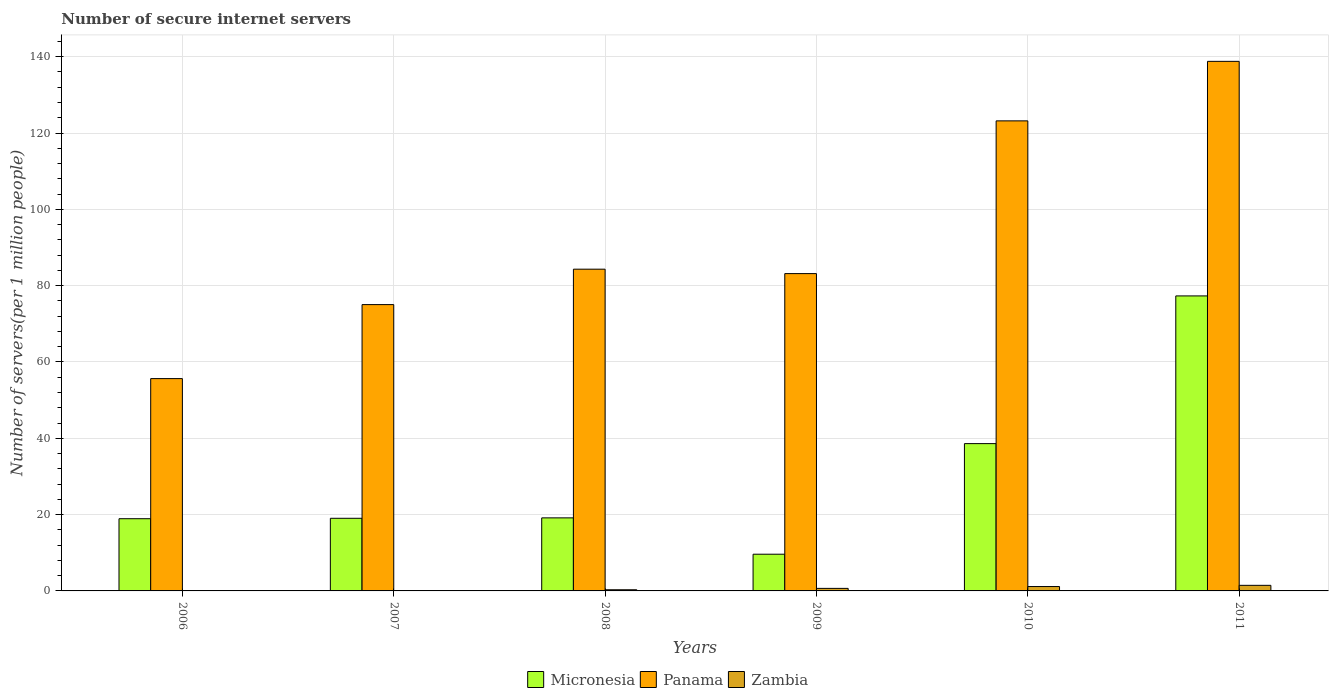How many different coloured bars are there?
Ensure brevity in your answer.  3. How many groups of bars are there?
Offer a terse response. 6. Are the number of bars per tick equal to the number of legend labels?
Make the answer very short. Yes. Are the number of bars on each tick of the X-axis equal?
Provide a succinct answer. Yes. How many bars are there on the 6th tick from the left?
Offer a very short reply. 3. What is the label of the 4th group of bars from the left?
Offer a very short reply. 2009. In how many cases, is the number of bars for a given year not equal to the number of legend labels?
Provide a succinct answer. 0. What is the number of secure internet servers in Zambia in 2006?
Your answer should be compact. 0.08. Across all years, what is the maximum number of secure internet servers in Zambia?
Offer a very short reply. 1.46. Across all years, what is the minimum number of secure internet servers in Micronesia?
Your answer should be very brief. 9.62. What is the total number of secure internet servers in Panama in the graph?
Your answer should be compact. 560.13. What is the difference between the number of secure internet servers in Panama in 2006 and that in 2009?
Ensure brevity in your answer.  -27.52. What is the difference between the number of secure internet servers in Zambia in 2007 and the number of secure internet servers in Micronesia in 2006?
Your answer should be very brief. -18.85. What is the average number of secure internet servers in Zambia per year?
Your answer should be very brief. 0.62. In the year 2010, what is the difference between the number of secure internet servers in Micronesia and number of secure internet servers in Panama?
Your answer should be compact. -84.58. What is the ratio of the number of secure internet servers in Panama in 2006 to that in 2010?
Your response must be concise. 0.45. Is the difference between the number of secure internet servers in Micronesia in 2009 and 2010 greater than the difference between the number of secure internet servers in Panama in 2009 and 2010?
Give a very brief answer. Yes. What is the difference between the highest and the second highest number of secure internet servers in Zambia?
Ensure brevity in your answer.  0.31. What is the difference between the highest and the lowest number of secure internet servers in Zambia?
Your answer should be compact. 1.39. In how many years, is the number of secure internet servers in Micronesia greater than the average number of secure internet servers in Micronesia taken over all years?
Your answer should be very brief. 2. What does the 2nd bar from the left in 2009 represents?
Offer a very short reply. Panama. What does the 2nd bar from the right in 2008 represents?
Give a very brief answer. Panama. Is it the case that in every year, the sum of the number of secure internet servers in Zambia and number of secure internet servers in Panama is greater than the number of secure internet servers in Micronesia?
Ensure brevity in your answer.  Yes. What is the difference between two consecutive major ticks on the Y-axis?
Make the answer very short. 20. Are the values on the major ticks of Y-axis written in scientific E-notation?
Offer a terse response. No. Does the graph contain any zero values?
Your answer should be compact. No. Where does the legend appear in the graph?
Provide a succinct answer. Bottom center. How are the legend labels stacked?
Your answer should be compact. Horizontal. What is the title of the graph?
Ensure brevity in your answer.  Number of secure internet servers. Does "Namibia" appear as one of the legend labels in the graph?
Provide a succinct answer. No. What is the label or title of the X-axis?
Provide a succinct answer. Years. What is the label or title of the Y-axis?
Keep it short and to the point. Number of servers(per 1 million people). What is the Number of servers(per 1 million people) of Micronesia in 2006?
Provide a short and direct response. 18.93. What is the Number of servers(per 1 million people) of Panama in 2006?
Ensure brevity in your answer.  55.64. What is the Number of servers(per 1 million people) in Zambia in 2006?
Offer a terse response. 0.08. What is the Number of servers(per 1 million people) in Micronesia in 2007?
Offer a very short reply. 19.03. What is the Number of servers(per 1 million people) in Panama in 2007?
Make the answer very short. 75.03. What is the Number of servers(per 1 million people) in Zambia in 2007?
Keep it short and to the point. 0.08. What is the Number of servers(per 1 million people) of Micronesia in 2008?
Keep it short and to the point. 19.14. What is the Number of servers(per 1 million people) of Panama in 2008?
Offer a very short reply. 84.32. What is the Number of servers(per 1 million people) of Zambia in 2008?
Your answer should be very brief. 0.31. What is the Number of servers(per 1 million people) of Micronesia in 2009?
Offer a very short reply. 9.62. What is the Number of servers(per 1 million people) in Panama in 2009?
Your answer should be compact. 83.16. What is the Number of servers(per 1 million people) in Zambia in 2009?
Your answer should be compact. 0.67. What is the Number of servers(per 1 million people) of Micronesia in 2010?
Provide a succinct answer. 38.6. What is the Number of servers(per 1 million people) in Panama in 2010?
Offer a very short reply. 123.19. What is the Number of servers(per 1 million people) in Zambia in 2010?
Your answer should be compact. 1.15. What is the Number of servers(per 1 million people) in Micronesia in 2011?
Give a very brief answer. 77.31. What is the Number of servers(per 1 million people) of Panama in 2011?
Provide a short and direct response. 138.78. What is the Number of servers(per 1 million people) in Zambia in 2011?
Your answer should be very brief. 1.46. Across all years, what is the maximum Number of servers(per 1 million people) of Micronesia?
Your answer should be very brief. 77.31. Across all years, what is the maximum Number of servers(per 1 million people) of Panama?
Offer a very short reply. 138.78. Across all years, what is the maximum Number of servers(per 1 million people) of Zambia?
Keep it short and to the point. 1.46. Across all years, what is the minimum Number of servers(per 1 million people) in Micronesia?
Your answer should be very brief. 9.62. Across all years, what is the minimum Number of servers(per 1 million people) in Panama?
Give a very brief answer. 55.64. Across all years, what is the minimum Number of servers(per 1 million people) of Zambia?
Provide a succinct answer. 0.08. What is the total Number of servers(per 1 million people) in Micronesia in the graph?
Provide a short and direct response. 182.64. What is the total Number of servers(per 1 million people) in Panama in the graph?
Your answer should be very brief. 560.13. What is the total Number of servers(per 1 million people) of Zambia in the graph?
Your response must be concise. 3.74. What is the difference between the Number of servers(per 1 million people) of Micronesia in 2006 and that in 2007?
Provide a short and direct response. -0.11. What is the difference between the Number of servers(per 1 million people) of Panama in 2006 and that in 2007?
Ensure brevity in your answer.  -19.39. What is the difference between the Number of servers(per 1 million people) in Zambia in 2006 and that in 2007?
Make the answer very short. 0. What is the difference between the Number of servers(per 1 million people) in Micronesia in 2006 and that in 2008?
Ensure brevity in your answer.  -0.22. What is the difference between the Number of servers(per 1 million people) of Panama in 2006 and that in 2008?
Provide a short and direct response. -28.67. What is the difference between the Number of servers(per 1 million people) in Zambia in 2006 and that in 2008?
Ensure brevity in your answer.  -0.22. What is the difference between the Number of servers(per 1 million people) of Micronesia in 2006 and that in 2009?
Make the answer very short. 9.31. What is the difference between the Number of servers(per 1 million people) of Panama in 2006 and that in 2009?
Your answer should be compact. -27.52. What is the difference between the Number of servers(per 1 million people) in Zambia in 2006 and that in 2009?
Provide a succinct answer. -0.59. What is the difference between the Number of servers(per 1 million people) of Micronesia in 2006 and that in 2010?
Offer a terse response. -19.68. What is the difference between the Number of servers(per 1 million people) of Panama in 2006 and that in 2010?
Your answer should be compact. -67.54. What is the difference between the Number of servers(per 1 million people) in Zambia in 2006 and that in 2010?
Give a very brief answer. -1.07. What is the difference between the Number of servers(per 1 million people) in Micronesia in 2006 and that in 2011?
Offer a terse response. -58.39. What is the difference between the Number of servers(per 1 million people) in Panama in 2006 and that in 2011?
Offer a very short reply. -83.14. What is the difference between the Number of servers(per 1 million people) in Zambia in 2006 and that in 2011?
Your answer should be compact. -1.38. What is the difference between the Number of servers(per 1 million people) of Micronesia in 2007 and that in 2008?
Your answer should be very brief. -0.11. What is the difference between the Number of servers(per 1 million people) of Panama in 2007 and that in 2008?
Keep it short and to the point. -9.28. What is the difference between the Number of servers(per 1 million people) in Zambia in 2007 and that in 2008?
Make the answer very short. -0.23. What is the difference between the Number of servers(per 1 million people) of Micronesia in 2007 and that in 2009?
Make the answer very short. 9.41. What is the difference between the Number of servers(per 1 million people) of Panama in 2007 and that in 2009?
Offer a very short reply. -8.13. What is the difference between the Number of servers(per 1 million people) of Zambia in 2007 and that in 2009?
Give a very brief answer. -0.59. What is the difference between the Number of servers(per 1 million people) in Micronesia in 2007 and that in 2010?
Provide a succinct answer. -19.57. What is the difference between the Number of servers(per 1 million people) in Panama in 2007 and that in 2010?
Ensure brevity in your answer.  -48.15. What is the difference between the Number of servers(per 1 million people) in Zambia in 2007 and that in 2010?
Make the answer very short. -1.07. What is the difference between the Number of servers(per 1 million people) of Micronesia in 2007 and that in 2011?
Provide a succinct answer. -58.28. What is the difference between the Number of servers(per 1 million people) of Panama in 2007 and that in 2011?
Your answer should be very brief. -63.75. What is the difference between the Number of servers(per 1 million people) of Zambia in 2007 and that in 2011?
Your answer should be very brief. -1.39. What is the difference between the Number of servers(per 1 million people) in Micronesia in 2008 and that in 2009?
Make the answer very short. 9.52. What is the difference between the Number of servers(per 1 million people) in Panama in 2008 and that in 2009?
Give a very brief answer. 1.16. What is the difference between the Number of servers(per 1 million people) of Zambia in 2008 and that in 2009?
Ensure brevity in your answer.  -0.36. What is the difference between the Number of servers(per 1 million people) of Micronesia in 2008 and that in 2010?
Make the answer very short. -19.46. What is the difference between the Number of servers(per 1 million people) of Panama in 2008 and that in 2010?
Your response must be concise. -38.87. What is the difference between the Number of servers(per 1 million people) of Zambia in 2008 and that in 2010?
Provide a succinct answer. -0.84. What is the difference between the Number of servers(per 1 million people) in Micronesia in 2008 and that in 2011?
Keep it short and to the point. -58.17. What is the difference between the Number of servers(per 1 million people) in Panama in 2008 and that in 2011?
Ensure brevity in your answer.  -54.47. What is the difference between the Number of servers(per 1 million people) of Zambia in 2008 and that in 2011?
Provide a succinct answer. -1.16. What is the difference between the Number of servers(per 1 million people) of Micronesia in 2009 and that in 2010?
Make the answer very short. -28.98. What is the difference between the Number of servers(per 1 million people) of Panama in 2009 and that in 2010?
Make the answer very short. -40.03. What is the difference between the Number of servers(per 1 million people) of Zambia in 2009 and that in 2010?
Provide a succinct answer. -0.48. What is the difference between the Number of servers(per 1 million people) of Micronesia in 2009 and that in 2011?
Your answer should be compact. -67.69. What is the difference between the Number of servers(per 1 million people) in Panama in 2009 and that in 2011?
Your response must be concise. -55.62. What is the difference between the Number of servers(per 1 million people) of Zambia in 2009 and that in 2011?
Give a very brief answer. -0.8. What is the difference between the Number of servers(per 1 million people) in Micronesia in 2010 and that in 2011?
Provide a short and direct response. -38.71. What is the difference between the Number of servers(per 1 million people) of Panama in 2010 and that in 2011?
Your answer should be very brief. -15.6. What is the difference between the Number of servers(per 1 million people) of Zambia in 2010 and that in 2011?
Offer a very short reply. -0.31. What is the difference between the Number of servers(per 1 million people) of Micronesia in 2006 and the Number of servers(per 1 million people) of Panama in 2007?
Make the answer very short. -56.11. What is the difference between the Number of servers(per 1 million people) of Micronesia in 2006 and the Number of servers(per 1 million people) of Zambia in 2007?
Give a very brief answer. 18.85. What is the difference between the Number of servers(per 1 million people) in Panama in 2006 and the Number of servers(per 1 million people) in Zambia in 2007?
Offer a very short reply. 55.57. What is the difference between the Number of servers(per 1 million people) in Micronesia in 2006 and the Number of servers(per 1 million people) in Panama in 2008?
Offer a very short reply. -65.39. What is the difference between the Number of servers(per 1 million people) of Micronesia in 2006 and the Number of servers(per 1 million people) of Zambia in 2008?
Your answer should be compact. 18.62. What is the difference between the Number of servers(per 1 million people) of Panama in 2006 and the Number of servers(per 1 million people) of Zambia in 2008?
Keep it short and to the point. 55.34. What is the difference between the Number of servers(per 1 million people) of Micronesia in 2006 and the Number of servers(per 1 million people) of Panama in 2009?
Offer a terse response. -64.23. What is the difference between the Number of servers(per 1 million people) of Micronesia in 2006 and the Number of servers(per 1 million people) of Zambia in 2009?
Provide a short and direct response. 18.26. What is the difference between the Number of servers(per 1 million people) of Panama in 2006 and the Number of servers(per 1 million people) of Zambia in 2009?
Make the answer very short. 54.98. What is the difference between the Number of servers(per 1 million people) of Micronesia in 2006 and the Number of servers(per 1 million people) of Panama in 2010?
Your response must be concise. -104.26. What is the difference between the Number of servers(per 1 million people) of Micronesia in 2006 and the Number of servers(per 1 million people) of Zambia in 2010?
Ensure brevity in your answer.  17.78. What is the difference between the Number of servers(per 1 million people) in Panama in 2006 and the Number of servers(per 1 million people) in Zambia in 2010?
Your answer should be compact. 54.49. What is the difference between the Number of servers(per 1 million people) in Micronesia in 2006 and the Number of servers(per 1 million people) in Panama in 2011?
Provide a short and direct response. -119.86. What is the difference between the Number of servers(per 1 million people) of Micronesia in 2006 and the Number of servers(per 1 million people) of Zambia in 2011?
Make the answer very short. 17.46. What is the difference between the Number of servers(per 1 million people) in Panama in 2006 and the Number of servers(per 1 million people) in Zambia in 2011?
Your response must be concise. 54.18. What is the difference between the Number of servers(per 1 million people) in Micronesia in 2007 and the Number of servers(per 1 million people) in Panama in 2008?
Ensure brevity in your answer.  -65.28. What is the difference between the Number of servers(per 1 million people) of Micronesia in 2007 and the Number of servers(per 1 million people) of Zambia in 2008?
Ensure brevity in your answer.  18.73. What is the difference between the Number of servers(per 1 million people) of Panama in 2007 and the Number of servers(per 1 million people) of Zambia in 2008?
Ensure brevity in your answer.  74.73. What is the difference between the Number of servers(per 1 million people) of Micronesia in 2007 and the Number of servers(per 1 million people) of Panama in 2009?
Your response must be concise. -64.13. What is the difference between the Number of servers(per 1 million people) in Micronesia in 2007 and the Number of servers(per 1 million people) in Zambia in 2009?
Ensure brevity in your answer.  18.37. What is the difference between the Number of servers(per 1 million people) of Panama in 2007 and the Number of servers(per 1 million people) of Zambia in 2009?
Your answer should be very brief. 74.37. What is the difference between the Number of servers(per 1 million people) of Micronesia in 2007 and the Number of servers(per 1 million people) of Panama in 2010?
Offer a very short reply. -104.15. What is the difference between the Number of servers(per 1 million people) in Micronesia in 2007 and the Number of servers(per 1 million people) in Zambia in 2010?
Offer a terse response. 17.88. What is the difference between the Number of servers(per 1 million people) of Panama in 2007 and the Number of servers(per 1 million people) of Zambia in 2010?
Give a very brief answer. 73.89. What is the difference between the Number of servers(per 1 million people) in Micronesia in 2007 and the Number of servers(per 1 million people) in Panama in 2011?
Make the answer very short. -119.75. What is the difference between the Number of servers(per 1 million people) in Micronesia in 2007 and the Number of servers(per 1 million people) in Zambia in 2011?
Keep it short and to the point. 17.57. What is the difference between the Number of servers(per 1 million people) in Panama in 2007 and the Number of servers(per 1 million people) in Zambia in 2011?
Offer a very short reply. 73.57. What is the difference between the Number of servers(per 1 million people) of Micronesia in 2008 and the Number of servers(per 1 million people) of Panama in 2009?
Offer a very short reply. -64.02. What is the difference between the Number of servers(per 1 million people) of Micronesia in 2008 and the Number of servers(per 1 million people) of Zambia in 2009?
Offer a very short reply. 18.48. What is the difference between the Number of servers(per 1 million people) in Panama in 2008 and the Number of servers(per 1 million people) in Zambia in 2009?
Provide a short and direct response. 83.65. What is the difference between the Number of servers(per 1 million people) of Micronesia in 2008 and the Number of servers(per 1 million people) of Panama in 2010?
Ensure brevity in your answer.  -104.04. What is the difference between the Number of servers(per 1 million people) in Micronesia in 2008 and the Number of servers(per 1 million people) in Zambia in 2010?
Offer a terse response. 17.99. What is the difference between the Number of servers(per 1 million people) of Panama in 2008 and the Number of servers(per 1 million people) of Zambia in 2010?
Provide a short and direct response. 83.17. What is the difference between the Number of servers(per 1 million people) of Micronesia in 2008 and the Number of servers(per 1 million people) of Panama in 2011?
Provide a short and direct response. -119.64. What is the difference between the Number of servers(per 1 million people) of Micronesia in 2008 and the Number of servers(per 1 million people) of Zambia in 2011?
Offer a very short reply. 17.68. What is the difference between the Number of servers(per 1 million people) in Panama in 2008 and the Number of servers(per 1 million people) in Zambia in 2011?
Your answer should be very brief. 82.85. What is the difference between the Number of servers(per 1 million people) of Micronesia in 2009 and the Number of servers(per 1 million people) of Panama in 2010?
Ensure brevity in your answer.  -113.57. What is the difference between the Number of servers(per 1 million people) of Micronesia in 2009 and the Number of servers(per 1 million people) of Zambia in 2010?
Make the answer very short. 8.47. What is the difference between the Number of servers(per 1 million people) of Panama in 2009 and the Number of servers(per 1 million people) of Zambia in 2010?
Your answer should be compact. 82.01. What is the difference between the Number of servers(per 1 million people) in Micronesia in 2009 and the Number of servers(per 1 million people) in Panama in 2011?
Your response must be concise. -129.17. What is the difference between the Number of servers(per 1 million people) in Micronesia in 2009 and the Number of servers(per 1 million people) in Zambia in 2011?
Offer a terse response. 8.15. What is the difference between the Number of servers(per 1 million people) of Panama in 2009 and the Number of servers(per 1 million people) of Zambia in 2011?
Provide a succinct answer. 81.7. What is the difference between the Number of servers(per 1 million people) of Micronesia in 2010 and the Number of servers(per 1 million people) of Panama in 2011?
Your response must be concise. -100.18. What is the difference between the Number of servers(per 1 million people) of Micronesia in 2010 and the Number of servers(per 1 million people) of Zambia in 2011?
Your response must be concise. 37.14. What is the difference between the Number of servers(per 1 million people) in Panama in 2010 and the Number of servers(per 1 million people) in Zambia in 2011?
Offer a terse response. 121.72. What is the average Number of servers(per 1 million people) in Micronesia per year?
Your answer should be very brief. 30.44. What is the average Number of servers(per 1 million people) of Panama per year?
Keep it short and to the point. 93.35. What is the average Number of servers(per 1 million people) in Zambia per year?
Provide a succinct answer. 0.62. In the year 2006, what is the difference between the Number of servers(per 1 million people) of Micronesia and Number of servers(per 1 million people) of Panama?
Offer a terse response. -36.72. In the year 2006, what is the difference between the Number of servers(per 1 million people) in Micronesia and Number of servers(per 1 million people) in Zambia?
Your answer should be compact. 18.84. In the year 2006, what is the difference between the Number of servers(per 1 million people) of Panama and Number of servers(per 1 million people) of Zambia?
Offer a terse response. 55.56. In the year 2007, what is the difference between the Number of servers(per 1 million people) of Micronesia and Number of servers(per 1 million people) of Panama?
Your response must be concise. -56. In the year 2007, what is the difference between the Number of servers(per 1 million people) of Micronesia and Number of servers(per 1 million people) of Zambia?
Ensure brevity in your answer.  18.95. In the year 2007, what is the difference between the Number of servers(per 1 million people) of Panama and Number of servers(per 1 million people) of Zambia?
Offer a very short reply. 74.96. In the year 2008, what is the difference between the Number of servers(per 1 million people) in Micronesia and Number of servers(per 1 million people) in Panama?
Give a very brief answer. -65.17. In the year 2008, what is the difference between the Number of servers(per 1 million people) in Micronesia and Number of servers(per 1 million people) in Zambia?
Your response must be concise. 18.84. In the year 2008, what is the difference between the Number of servers(per 1 million people) of Panama and Number of servers(per 1 million people) of Zambia?
Your response must be concise. 84.01. In the year 2009, what is the difference between the Number of servers(per 1 million people) of Micronesia and Number of servers(per 1 million people) of Panama?
Ensure brevity in your answer.  -73.54. In the year 2009, what is the difference between the Number of servers(per 1 million people) in Micronesia and Number of servers(per 1 million people) in Zambia?
Your response must be concise. 8.95. In the year 2009, what is the difference between the Number of servers(per 1 million people) in Panama and Number of servers(per 1 million people) in Zambia?
Ensure brevity in your answer.  82.49. In the year 2010, what is the difference between the Number of servers(per 1 million people) in Micronesia and Number of servers(per 1 million people) in Panama?
Make the answer very short. -84.58. In the year 2010, what is the difference between the Number of servers(per 1 million people) of Micronesia and Number of servers(per 1 million people) of Zambia?
Provide a short and direct response. 37.45. In the year 2010, what is the difference between the Number of servers(per 1 million people) of Panama and Number of servers(per 1 million people) of Zambia?
Your answer should be very brief. 122.04. In the year 2011, what is the difference between the Number of servers(per 1 million people) in Micronesia and Number of servers(per 1 million people) in Panama?
Provide a succinct answer. -61.47. In the year 2011, what is the difference between the Number of servers(per 1 million people) of Micronesia and Number of servers(per 1 million people) of Zambia?
Your answer should be compact. 75.85. In the year 2011, what is the difference between the Number of servers(per 1 million people) of Panama and Number of servers(per 1 million people) of Zambia?
Offer a very short reply. 137.32. What is the ratio of the Number of servers(per 1 million people) of Panama in 2006 to that in 2007?
Your answer should be compact. 0.74. What is the ratio of the Number of servers(per 1 million people) in Zambia in 2006 to that in 2007?
Ensure brevity in your answer.  1.03. What is the ratio of the Number of servers(per 1 million people) of Panama in 2006 to that in 2008?
Offer a very short reply. 0.66. What is the ratio of the Number of servers(per 1 million people) in Zambia in 2006 to that in 2008?
Your response must be concise. 0.26. What is the ratio of the Number of servers(per 1 million people) in Micronesia in 2006 to that in 2009?
Give a very brief answer. 1.97. What is the ratio of the Number of servers(per 1 million people) in Panama in 2006 to that in 2009?
Keep it short and to the point. 0.67. What is the ratio of the Number of servers(per 1 million people) of Zambia in 2006 to that in 2009?
Your response must be concise. 0.12. What is the ratio of the Number of servers(per 1 million people) of Micronesia in 2006 to that in 2010?
Provide a succinct answer. 0.49. What is the ratio of the Number of servers(per 1 million people) in Panama in 2006 to that in 2010?
Your answer should be very brief. 0.45. What is the ratio of the Number of servers(per 1 million people) in Zambia in 2006 to that in 2010?
Make the answer very short. 0.07. What is the ratio of the Number of servers(per 1 million people) in Micronesia in 2006 to that in 2011?
Your answer should be very brief. 0.24. What is the ratio of the Number of servers(per 1 million people) of Panama in 2006 to that in 2011?
Provide a succinct answer. 0.4. What is the ratio of the Number of servers(per 1 million people) in Zambia in 2006 to that in 2011?
Offer a very short reply. 0.06. What is the ratio of the Number of servers(per 1 million people) of Micronesia in 2007 to that in 2008?
Keep it short and to the point. 0.99. What is the ratio of the Number of servers(per 1 million people) of Panama in 2007 to that in 2008?
Offer a very short reply. 0.89. What is the ratio of the Number of servers(per 1 million people) in Zambia in 2007 to that in 2008?
Offer a terse response. 0.26. What is the ratio of the Number of servers(per 1 million people) in Micronesia in 2007 to that in 2009?
Provide a short and direct response. 1.98. What is the ratio of the Number of servers(per 1 million people) of Panama in 2007 to that in 2009?
Ensure brevity in your answer.  0.9. What is the ratio of the Number of servers(per 1 million people) of Zambia in 2007 to that in 2009?
Make the answer very short. 0.12. What is the ratio of the Number of servers(per 1 million people) in Micronesia in 2007 to that in 2010?
Provide a short and direct response. 0.49. What is the ratio of the Number of servers(per 1 million people) in Panama in 2007 to that in 2010?
Provide a short and direct response. 0.61. What is the ratio of the Number of servers(per 1 million people) in Zambia in 2007 to that in 2010?
Ensure brevity in your answer.  0.07. What is the ratio of the Number of servers(per 1 million people) in Micronesia in 2007 to that in 2011?
Provide a succinct answer. 0.25. What is the ratio of the Number of servers(per 1 million people) in Panama in 2007 to that in 2011?
Provide a succinct answer. 0.54. What is the ratio of the Number of servers(per 1 million people) in Zambia in 2007 to that in 2011?
Ensure brevity in your answer.  0.05. What is the ratio of the Number of servers(per 1 million people) of Micronesia in 2008 to that in 2009?
Offer a very short reply. 1.99. What is the ratio of the Number of servers(per 1 million people) in Panama in 2008 to that in 2009?
Ensure brevity in your answer.  1.01. What is the ratio of the Number of servers(per 1 million people) in Zambia in 2008 to that in 2009?
Provide a short and direct response. 0.46. What is the ratio of the Number of servers(per 1 million people) in Micronesia in 2008 to that in 2010?
Your response must be concise. 0.5. What is the ratio of the Number of servers(per 1 million people) of Panama in 2008 to that in 2010?
Offer a very short reply. 0.68. What is the ratio of the Number of servers(per 1 million people) in Zambia in 2008 to that in 2010?
Keep it short and to the point. 0.27. What is the ratio of the Number of servers(per 1 million people) in Micronesia in 2008 to that in 2011?
Provide a succinct answer. 0.25. What is the ratio of the Number of servers(per 1 million people) in Panama in 2008 to that in 2011?
Offer a terse response. 0.61. What is the ratio of the Number of servers(per 1 million people) of Zambia in 2008 to that in 2011?
Provide a short and direct response. 0.21. What is the ratio of the Number of servers(per 1 million people) of Micronesia in 2009 to that in 2010?
Make the answer very short. 0.25. What is the ratio of the Number of servers(per 1 million people) of Panama in 2009 to that in 2010?
Offer a terse response. 0.68. What is the ratio of the Number of servers(per 1 million people) in Zambia in 2009 to that in 2010?
Your answer should be very brief. 0.58. What is the ratio of the Number of servers(per 1 million people) of Micronesia in 2009 to that in 2011?
Make the answer very short. 0.12. What is the ratio of the Number of servers(per 1 million people) of Panama in 2009 to that in 2011?
Ensure brevity in your answer.  0.6. What is the ratio of the Number of servers(per 1 million people) of Zambia in 2009 to that in 2011?
Offer a very short reply. 0.46. What is the ratio of the Number of servers(per 1 million people) in Micronesia in 2010 to that in 2011?
Keep it short and to the point. 0.5. What is the ratio of the Number of servers(per 1 million people) in Panama in 2010 to that in 2011?
Your answer should be very brief. 0.89. What is the ratio of the Number of servers(per 1 million people) of Zambia in 2010 to that in 2011?
Your answer should be very brief. 0.79. What is the difference between the highest and the second highest Number of servers(per 1 million people) of Micronesia?
Offer a terse response. 38.71. What is the difference between the highest and the second highest Number of servers(per 1 million people) in Panama?
Make the answer very short. 15.6. What is the difference between the highest and the second highest Number of servers(per 1 million people) in Zambia?
Make the answer very short. 0.31. What is the difference between the highest and the lowest Number of servers(per 1 million people) in Micronesia?
Provide a short and direct response. 67.69. What is the difference between the highest and the lowest Number of servers(per 1 million people) in Panama?
Ensure brevity in your answer.  83.14. What is the difference between the highest and the lowest Number of servers(per 1 million people) in Zambia?
Keep it short and to the point. 1.39. 